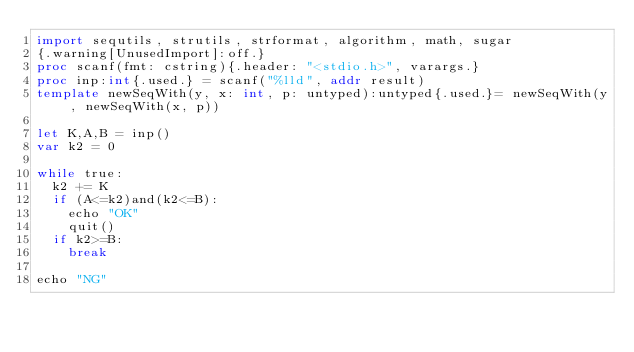Convert code to text. <code><loc_0><loc_0><loc_500><loc_500><_Nim_>import sequtils, strutils, strformat, algorithm, math, sugar
{.warning[UnusedImport]:off.}
proc scanf(fmt: cstring){.header: "<stdio.h>", varargs.}
proc inp:int{.used.} = scanf("%lld", addr result)
template newSeqWith(y, x: int, p: untyped):untyped{.used.}= newSeqWith(y, newSeqWith(x, p))

let K,A,B = inp()
var k2 = 0

while true:
  k2 += K
  if (A<=k2)and(k2<=B):
    echo "OK"
    quit()
  if k2>=B:
    break

echo "NG"
</code> 